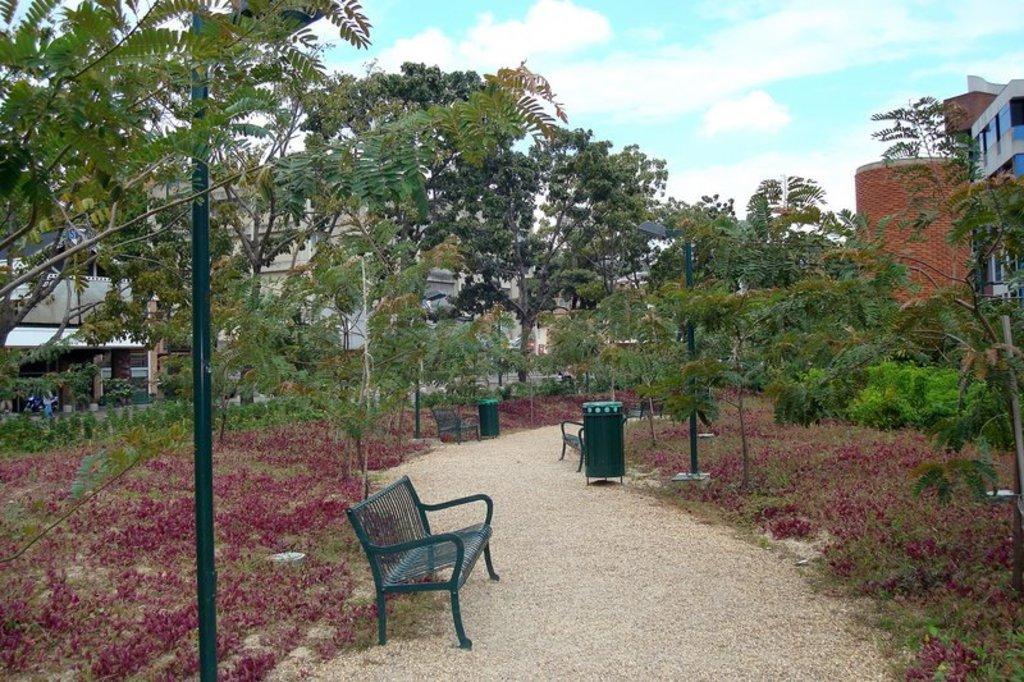Could you give a brief overview of what you see in this image? In this picture we can see there are benches, dustbins, poles on the walkway. On the left side of the benches there are plants, trees, buildings and the sky. 